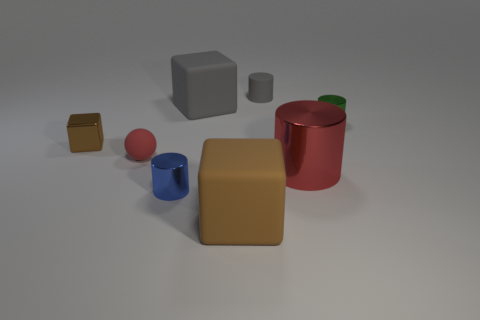Add 2 big red shiny blocks. How many objects exist? 10 Subtract all blocks. How many objects are left? 5 Add 8 big cylinders. How many big cylinders are left? 9 Add 1 blue matte cylinders. How many blue matte cylinders exist? 1 Subtract 1 green cylinders. How many objects are left? 7 Subtract all small things. Subtract all balls. How many objects are left? 2 